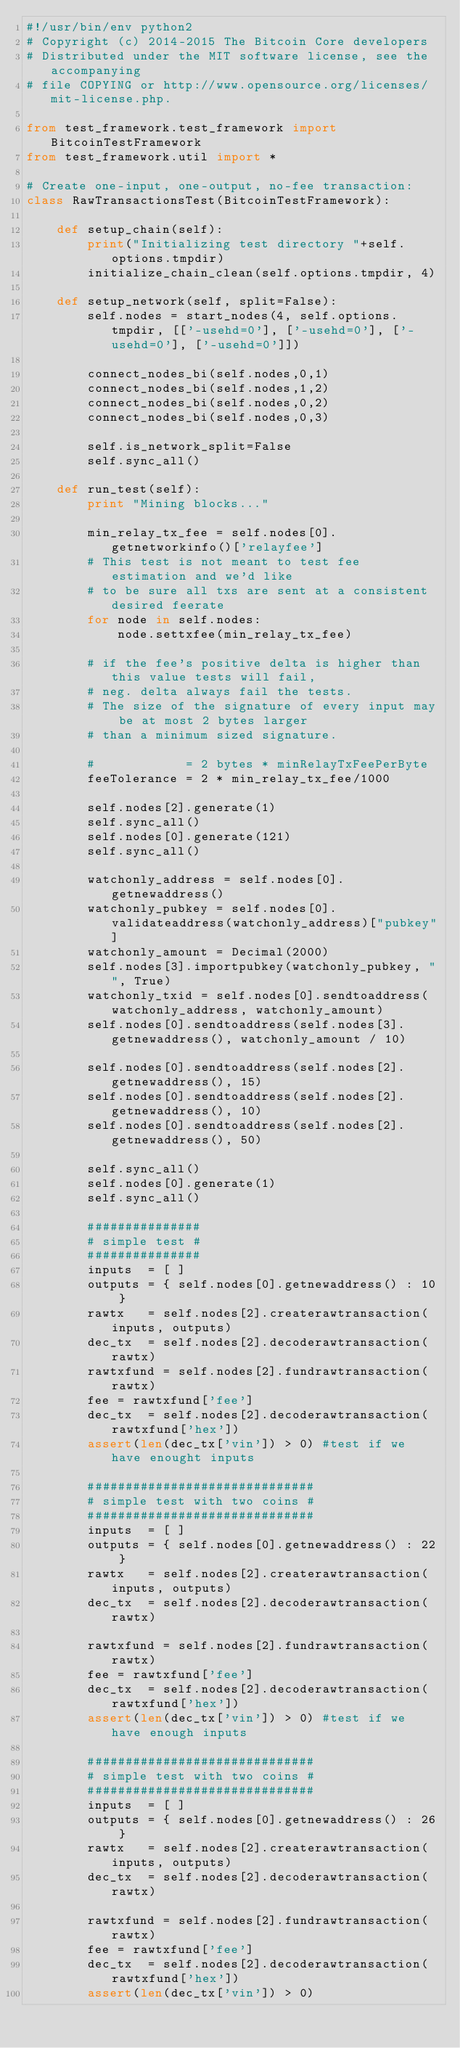<code> <loc_0><loc_0><loc_500><loc_500><_Python_>#!/usr/bin/env python2
# Copyright (c) 2014-2015 The Bitcoin Core developers
# Distributed under the MIT software license, see the accompanying
# file COPYING or http://www.opensource.org/licenses/mit-license.php.

from test_framework.test_framework import BitcoinTestFramework
from test_framework.util import *

# Create one-input, one-output, no-fee transaction:
class RawTransactionsTest(BitcoinTestFramework):

    def setup_chain(self):
        print("Initializing test directory "+self.options.tmpdir)
        initialize_chain_clean(self.options.tmpdir, 4)

    def setup_network(self, split=False):
        self.nodes = start_nodes(4, self.options.tmpdir, [['-usehd=0'], ['-usehd=0'], ['-usehd=0'], ['-usehd=0']])

        connect_nodes_bi(self.nodes,0,1)
        connect_nodes_bi(self.nodes,1,2)
        connect_nodes_bi(self.nodes,0,2)
        connect_nodes_bi(self.nodes,0,3)

        self.is_network_split=False
        self.sync_all()

    def run_test(self):
        print "Mining blocks..."

        min_relay_tx_fee = self.nodes[0].getnetworkinfo()['relayfee']
        # This test is not meant to test fee estimation and we'd like
        # to be sure all txs are sent at a consistent desired feerate
        for node in self.nodes:
            node.settxfee(min_relay_tx_fee)

        # if the fee's positive delta is higher than this value tests will fail,
        # neg. delta always fail the tests.
        # The size of the signature of every input may be at most 2 bytes larger
        # than a minimum sized signature.

        #            = 2 bytes * minRelayTxFeePerByte
        feeTolerance = 2 * min_relay_tx_fee/1000

        self.nodes[2].generate(1)
        self.sync_all()
        self.nodes[0].generate(121)
        self.sync_all()

        watchonly_address = self.nodes[0].getnewaddress()
        watchonly_pubkey = self.nodes[0].validateaddress(watchonly_address)["pubkey"]
        watchonly_amount = Decimal(2000)
        self.nodes[3].importpubkey(watchonly_pubkey, "", True)
        watchonly_txid = self.nodes[0].sendtoaddress(watchonly_address, watchonly_amount)
        self.nodes[0].sendtoaddress(self.nodes[3].getnewaddress(), watchonly_amount / 10)

        self.nodes[0].sendtoaddress(self.nodes[2].getnewaddress(), 15)
        self.nodes[0].sendtoaddress(self.nodes[2].getnewaddress(), 10)
        self.nodes[0].sendtoaddress(self.nodes[2].getnewaddress(), 50)

        self.sync_all()
        self.nodes[0].generate(1)
        self.sync_all()

        ###############
        # simple test #
        ###############
        inputs  = [ ]
        outputs = { self.nodes[0].getnewaddress() : 10 }
        rawtx   = self.nodes[2].createrawtransaction(inputs, outputs)
        dec_tx  = self.nodes[2].decoderawtransaction(rawtx)
        rawtxfund = self.nodes[2].fundrawtransaction(rawtx)
        fee = rawtxfund['fee']
        dec_tx  = self.nodes[2].decoderawtransaction(rawtxfund['hex'])
        assert(len(dec_tx['vin']) > 0) #test if we have enought inputs

        ##############################
        # simple test with two coins #
        ##############################
        inputs  = [ ]
        outputs = { self.nodes[0].getnewaddress() : 22 }
        rawtx   = self.nodes[2].createrawtransaction(inputs, outputs)
        dec_tx  = self.nodes[2].decoderawtransaction(rawtx)

        rawtxfund = self.nodes[2].fundrawtransaction(rawtx)
        fee = rawtxfund['fee']
        dec_tx  = self.nodes[2].decoderawtransaction(rawtxfund['hex'])
        assert(len(dec_tx['vin']) > 0) #test if we have enough inputs

        ##############################
        # simple test with two coins #
        ##############################
        inputs  = [ ]
        outputs = { self.nodes[0].getnewaddress() : 26 }
        rawtx   = self.nodes[2].createrawtransaction(inputs, outputs)
        dec_tx  = self.nodes[2].decoderawtransaction(rawtx)

        rawtxfund = self.nodes[2].fundrawtransaction(rawtx)
        fee = rawtxfund['fee']
        dec_tx  = self.nodes[2].decoderawtransaction(rawtxfund['hex'])
        assert(len(dec_tx['vin']) > 0)</code> 